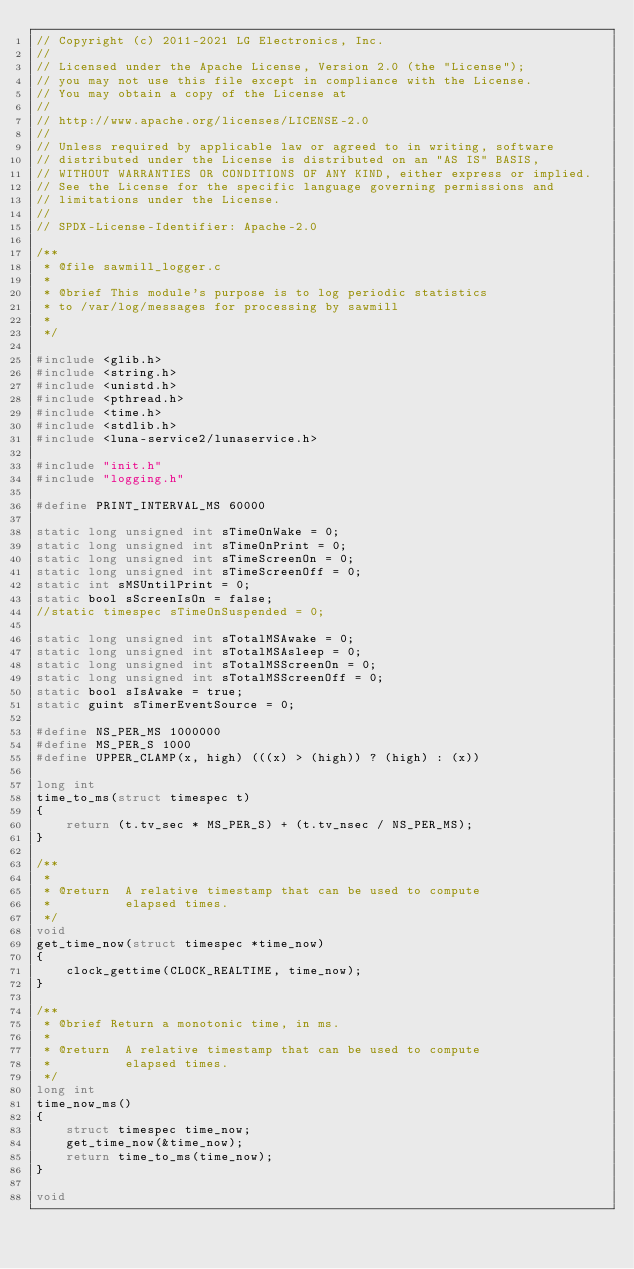Convert code to text. <code><loc_0><loc_0><loc_500><loc_500><_C_>// Copyright (c) 2011-2021 LG Electronics, Inc.
//
// Licensed under the Apache License, Version 2.0 (the "License");
// you may not use this file except in compliance with the License.
// You may obtain a copy of the License at
//
// http://www.apache.org/licenses/LICENSE-2.0
//
// Unless required by applicable law or agreed to in writing, software
// distributed under the License is distributed on an "AS IS" BASIS,
// WITHOUT WARRANTIES OR CONDITIONS OF ANY KIND, either express or implied.
// See the License for the specific language governing permissions and
// limitations under the License.
//
// SPDX-License-Identifier: Apache-2.0

/**
 * @file sawmill_logger.c
 *
 * @brief This module's purpose is to log periodic statistics
 * to /var/log/messages for processing by sawmill
 *
 */

#include <glib.h>
#include <string.h>
#include <unistd.h>
#include <pthread.h>
#include <time.h>
#include <stdlib.h>
#include <luna-service2/lunaservice.h>

#include "init.h"
#include "logging.h"

#define PRINT_INTERVAL_MS 60000

static long unsigned int sTimeOnWake = 0;
static long unsigned int sTimeOnPrint = 0;
static long unsigned int sTimeScreenOn = 0;
static long unsigned int sTimeScreenOff = 0;
static int sMSUntilPrint = 0;
static bool sScreenIsOn = false;
//static timespec sTimeOnSuspended = 0;

static long unsigned int sTotalMSAwake = 0;
static long unsigned int sTotalMSAsleep = 0;
static long unsigned int sTotalMSScreenOn = 0;
static long unsigned int sTotalMSScreenOff = 0;
static bool sIsAwake = true;
static guint sTimerEventSource = 0;

#define NS_PER_MS 1000000
#define MS_PER_S 1000
#define UPPER_CLAMP(x, high) (((x) > (high)) ? (high) : (x))

long int
time_to_ms(struct timespec t)
{
    return (t.tv_sec * MS_PER_S) + (t.tv_nsec / NS_PER_MS);
}

/**
 *
 * @return  A relative timestamp that can be used to compute
 *          elapsed times.
 */
void
get_time_now(struct timespec *time_now)
{
    clock_gettime(CLOCK_REALTIME, time_now);
}

/**
 * @brief Return a monotonic time, in ms.
 *
 * @return  A relative timestamp that can be used to compute
 *          elapsed times.
 */
long int
time_now_ms()
{
    struct timespec time_now;
    get_time_now(&time_now);
    return time_to_ms(time_now);
}

void</code> 